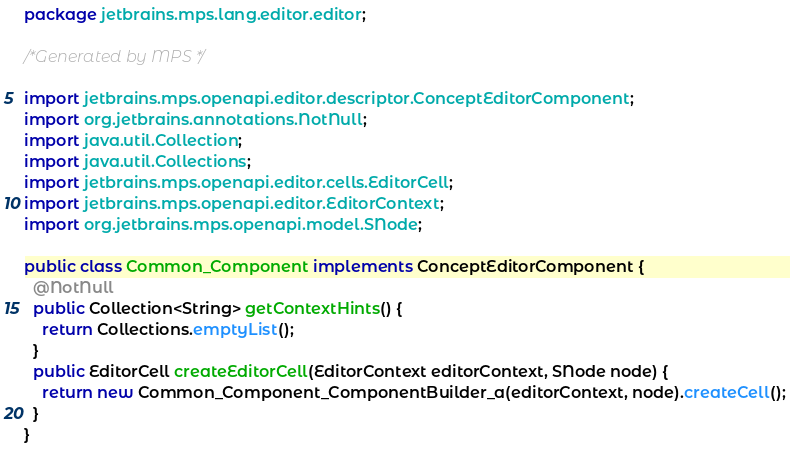Convert code to text. <code><loc_0><loc_0><loc_500><loc_500><_Java_>package jetbrains.mps.lang.editor.editor;

/*Generated by MPS */

import jetbrains.mps.openapi.editor.descriptor.ConceptEditorComponent;
import org.jetbrains.annotations.NotNull;
import java.util.Collection;
import java.util.Collections;
import jetbrains.mps.openapi.editor.cells.EditorCell;
import jetbrains.mps.openapi.editor.EditorContext;
import org.jetbrains.mps.openapi.model.SNode;

public class Common_Component implements ConceptEditorComponent {
  @NotNull
  public Collection<String> getContextHints() {
    return Collections.emptyList();
  }
  public EditorCell createEditorCell(EditorContext editorContext, SNode node) {
    return new Common_Component_ComponentBuilder_a(editorContext, node).createCell();
  }
}
</code> 